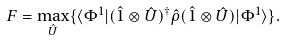Convert formula to latex. <formula><loc_0><loc_0><loc_500><loc_500>F = \underset { \hat { U } } { \max } \{ \langle \Phi ^ { 1 } | ( \hat { 1 } \otimes \hat { U } ) ^ { \dagger } \hat { \rho } ( \hat { 1 } \otimes \hat { U } ) | \Phi ^ { 1 } \rangle \} .</formula> 